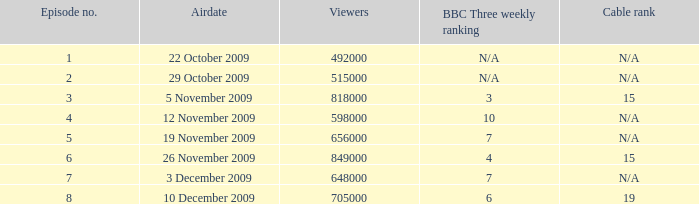What is the cable rating for bbc three's weekly ranking of not applicable? N/A, N/A. Could you help me parse every detail presented in this table? {'header': ['Episode no.', 'Airdate', 'Viewers', 'BBC Three weekly ranking', 'Cable rank'], 'rows': [['1', '22 October 2009', '492000', 'N/A', 'N/A'], ['2', '29 October 2009', '515000', 'N/A', 'N/A'], ['3', '5 November 2009', '818000', '3', '15'], ['4', '12 November 2009', '598000', '10', 'N/A'], ['5', '19 November 2009', '656000', '7', 'N/A'], ['6', '26 November 2009', '849000', '4', '15'], ['7', '3 December 2009', '648000', '7', 'N/A'], ['8', '10 December 2009', '705000', '6', '19']]} 